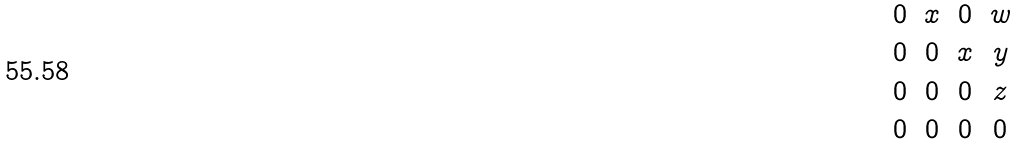Convert formula to latex. <formula><loc_0><loc_0><loc_500><loc_500>\begin{matrix} 0 & x & 0 & w \\ 0 & 0 & x & y \\ 0 & 0 & 0 & z \\ 0 & 0 & 0 & 0 \end{matrix}</formula> 